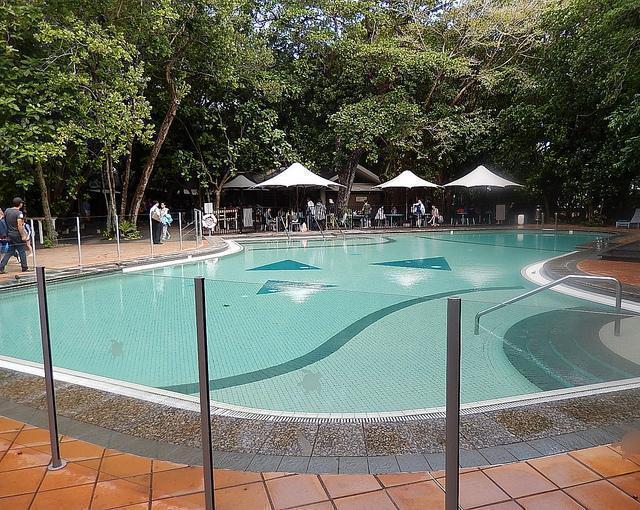What is the far end of the pool called?
Select the accurate response from the four choices given to answer the question.
Options: Deep side, adults only, deep zone, deep end. Deep end. 